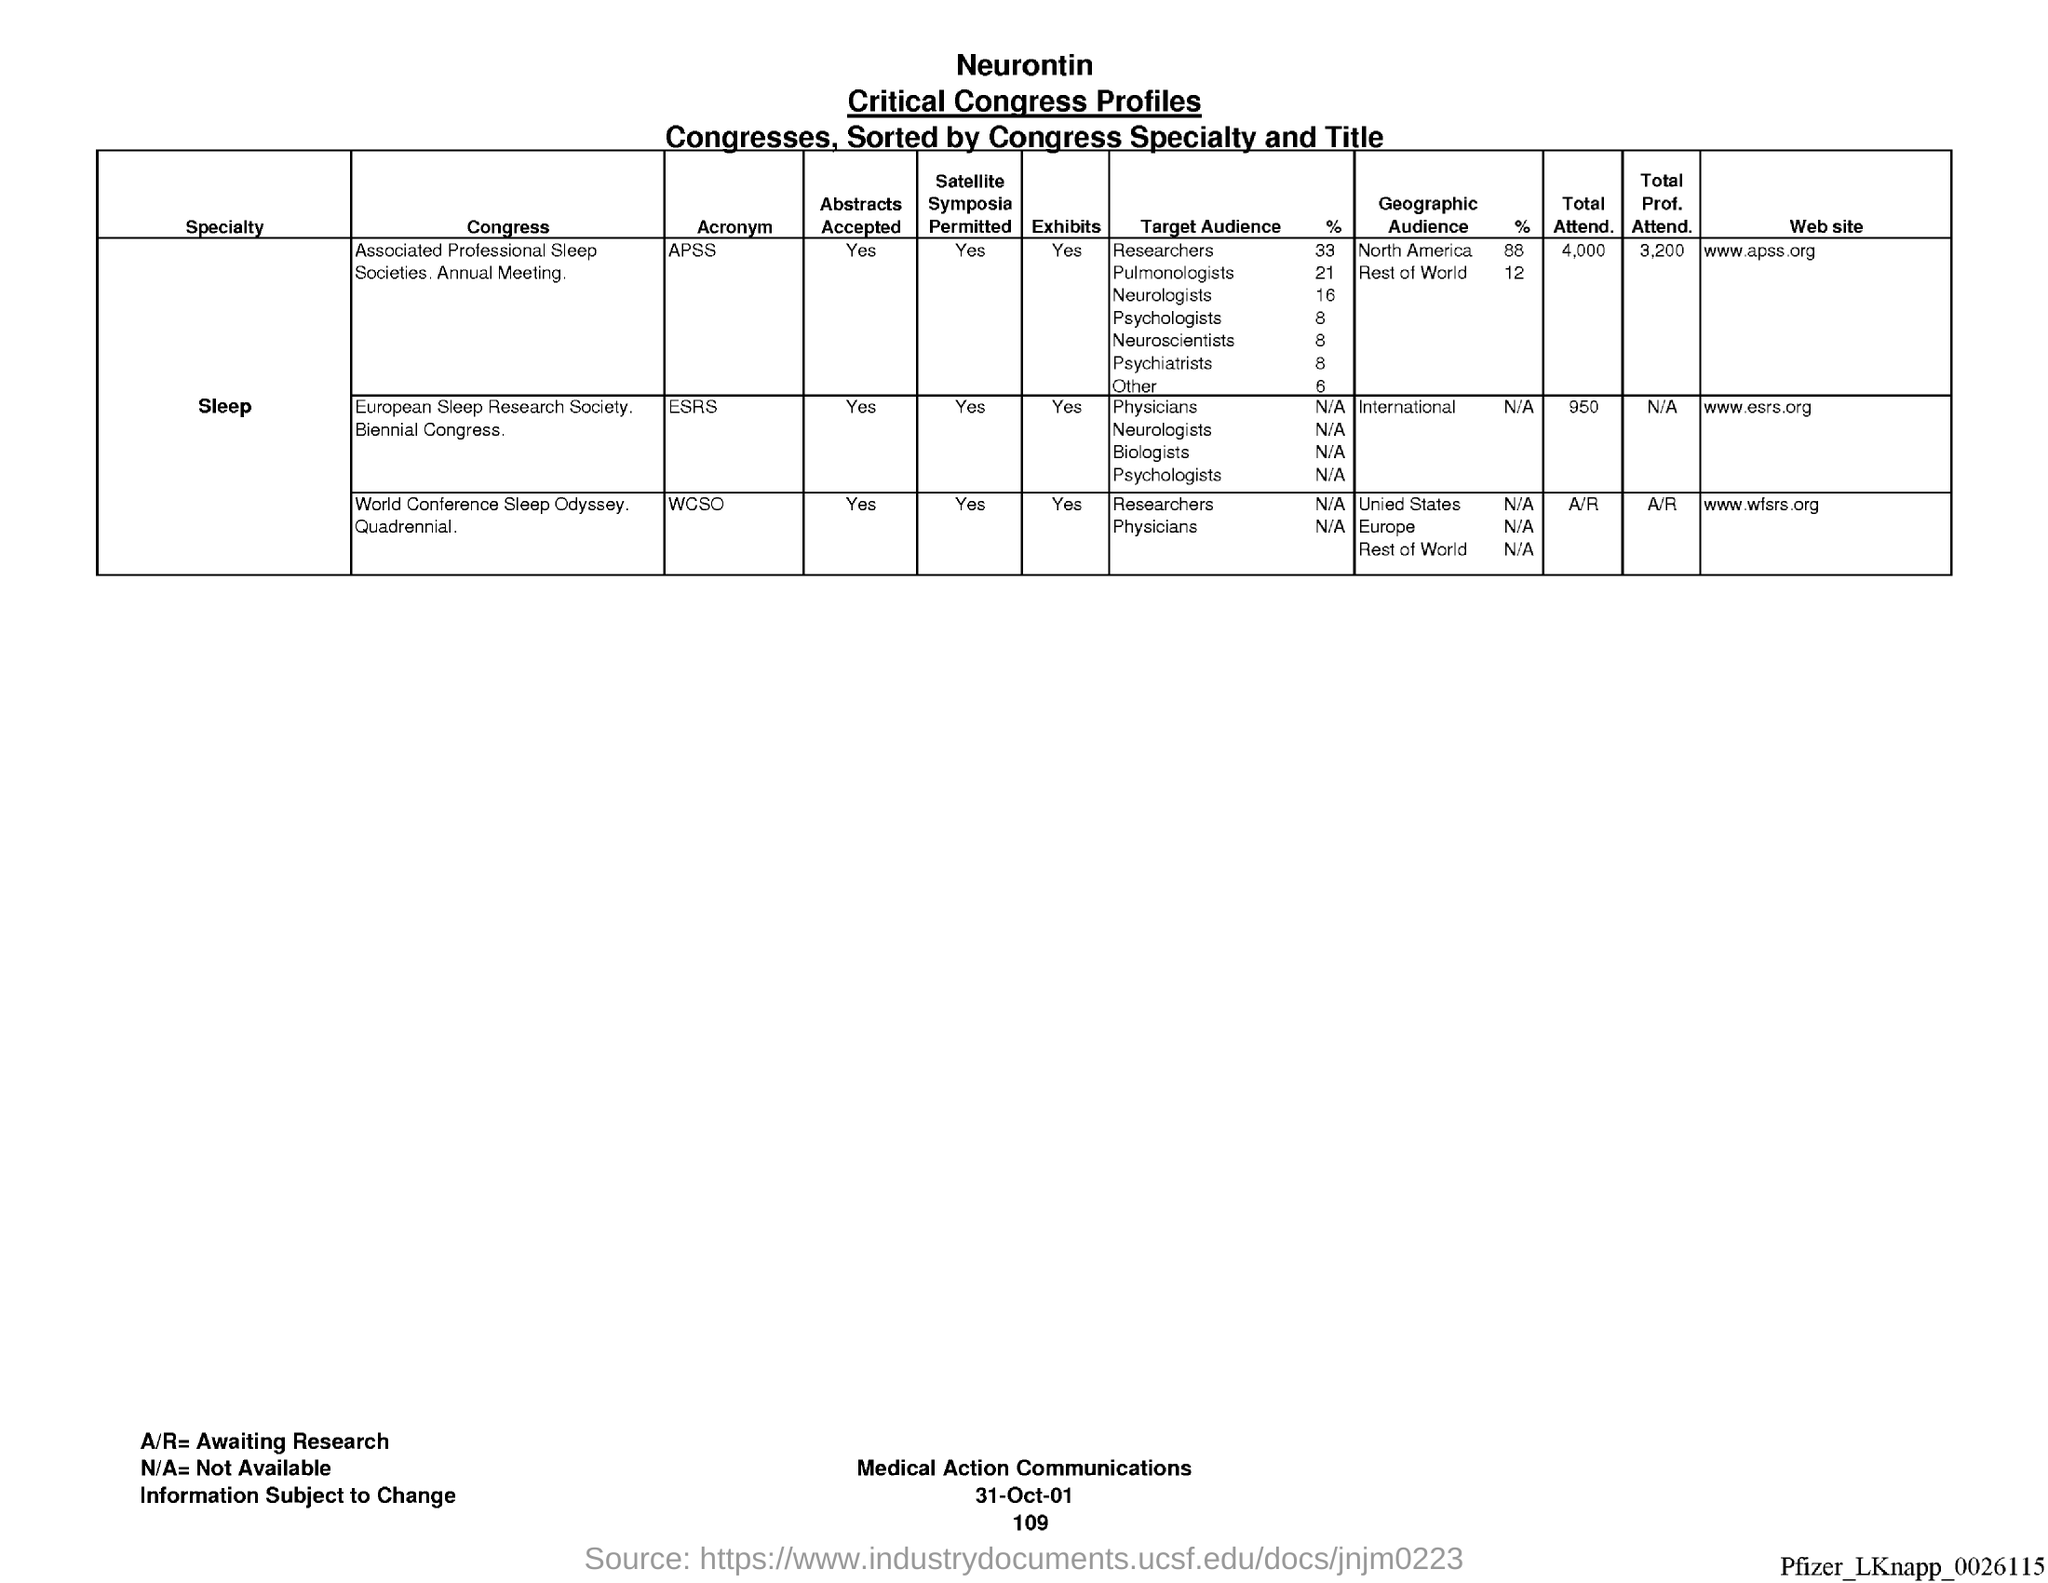Point out several critical features in this image. The total number of professional attendees at the APSS is 3,200. ESRS is the acronym for the Environmental Systems Research Institute. The website for ESRS is [www.esrs.org](http://www.esrs.org). The total attendance for the APSS is 4,000. The total number of professional attendance for the Environmental Science and Resource Management program is not available. The total attendance for the Emergency Services Recruitment Symposium was 950 people. 